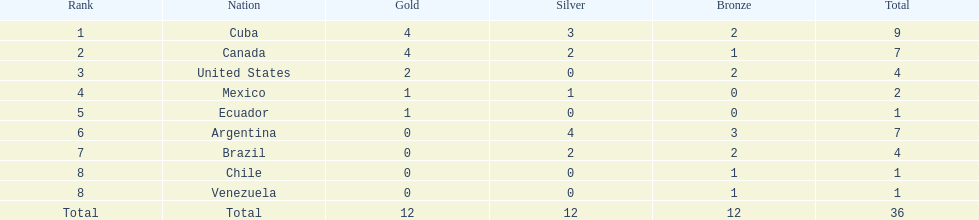Which country was victorious in obtaining gold but not silver? United States. 